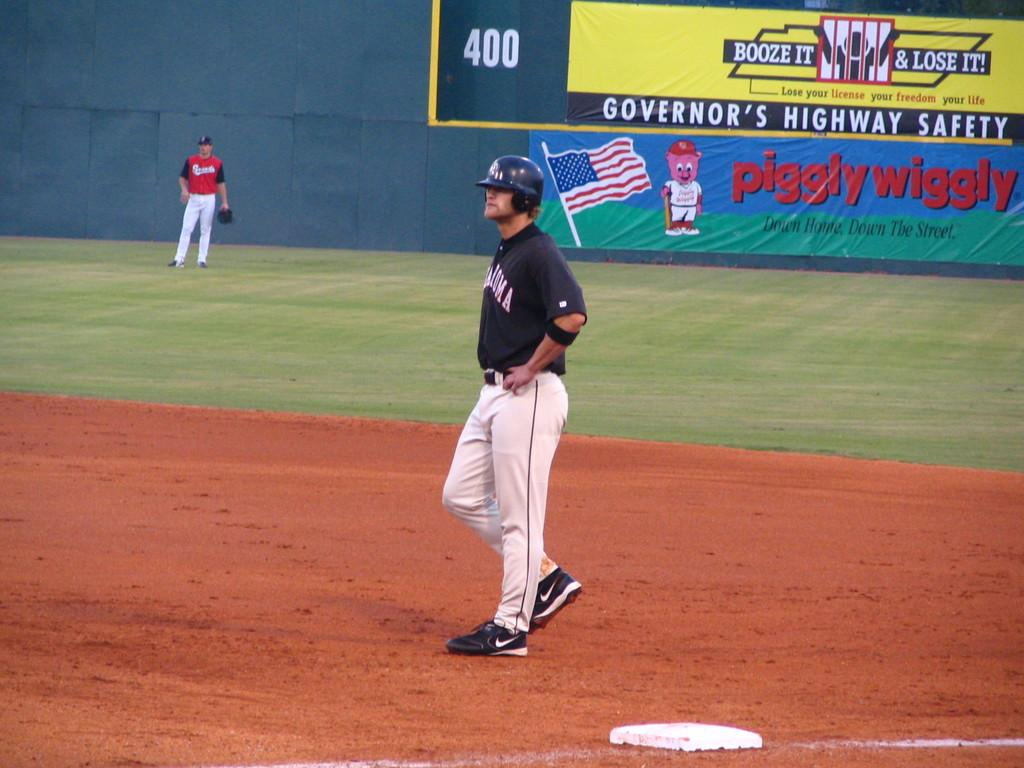<image>
Write a terse but informative summary of the picture. a person on the base during a game with a piggly wiggly ad behind them 